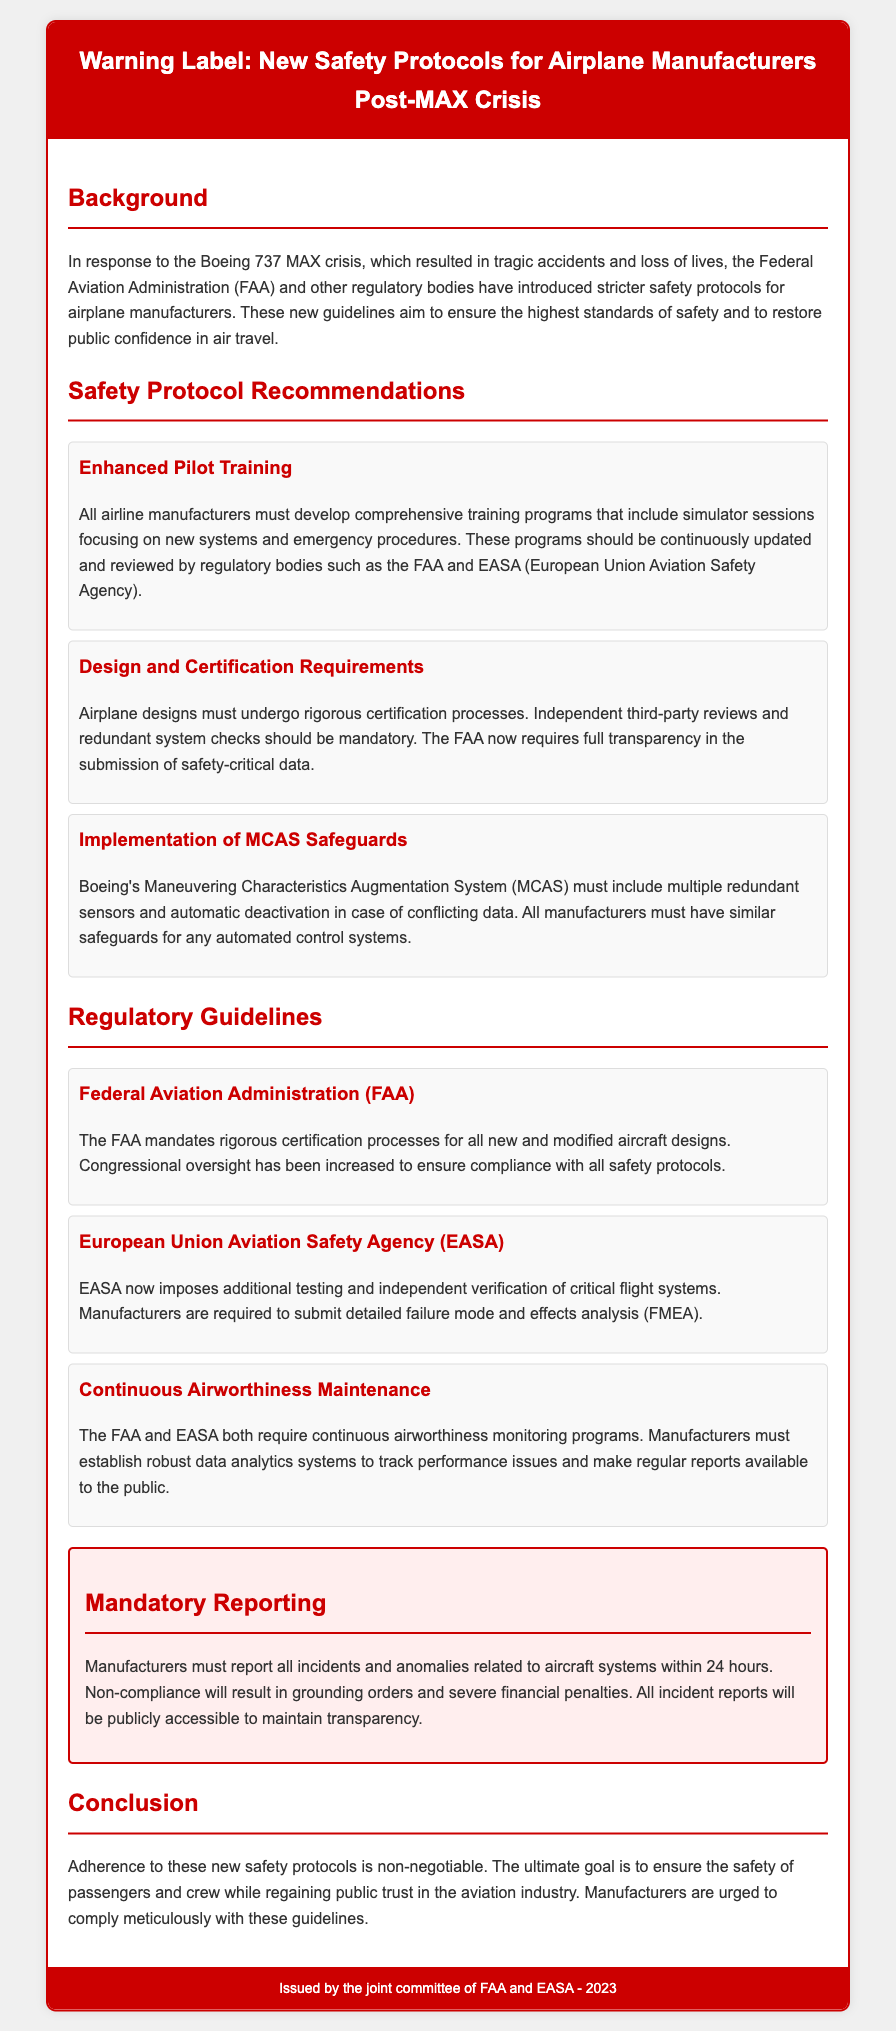what is the title of the document? The title is explicitly stated in the header of the document.
Answer: Warning Label: New Safety Protocols for Airplane Manufacturers Post-MAX Crisis what government agency oversees the new safety protocols? The document mentions the Federal Aviation Administration as a key regulatory body.
Answer: Federal Aviation Administration (FAA) how many recommendations are listed under Safety Protocol Recommendations? The document explicitly outlines multiple recommendations in that section.
Answer: Three what is one requirement for manufacturers regarding pilot training? One requirement is mentioned in the Enhanced Pilot Training section regarding training programs.
Answer: Comprehensive training programs which system must have multiple redundant sensors according to the recommendations? The document specifically refers to a system that requires redundant safeguards.
Answer: MCAS what is the timeframe for manufacturers to report incidents? The document provides a specific timeframe for reporting incidents related to aircraft systems.
Answer: 24 hours what must manufacturers submit to EASA as per the guidelines? The document states a specific type of analysis that manufacturers are required to submit.
Answer: Failure mode and effects analysis (FMEA) what happens if manufacturers fail to comply with the mandatory reporting? The document outlines consequences for non-compliance in a specific section.
Answer: Grounding orders and severe financial penalties 